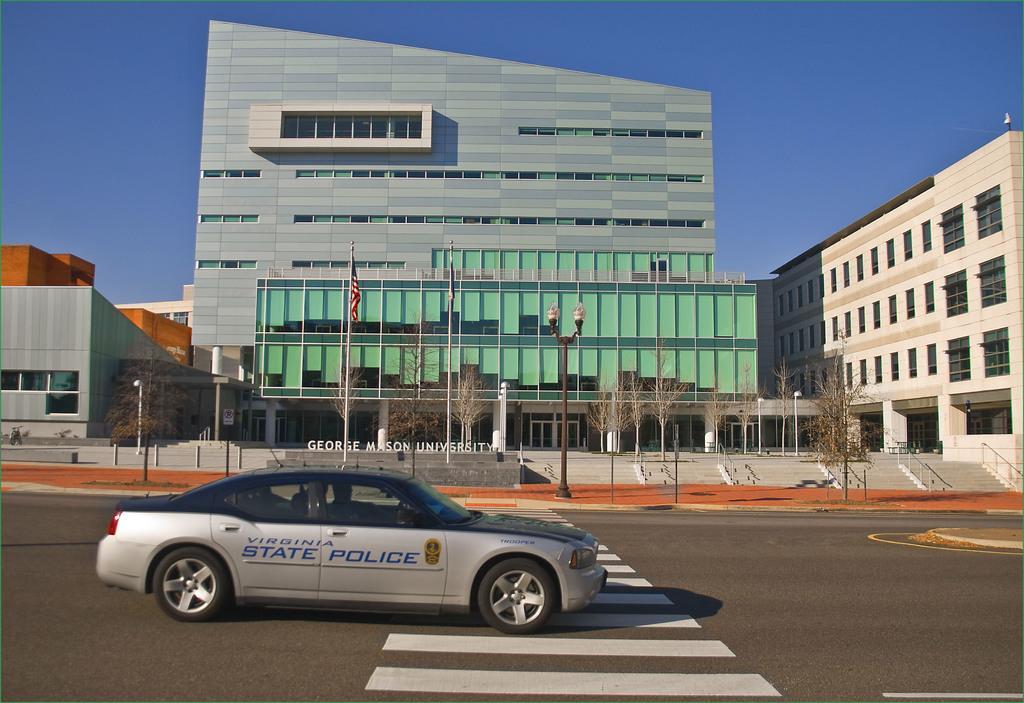In one or two sentences, can you explain what this image depicts? In this image we can see a car on the road. In the back there is a light pole. Also there are many trees. And there are many buildings. Also there are steps with railings. In the background there is sky. 